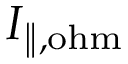Convert formula to latex. <formula><loc_0><loc_0><loc_500><loc_500>I _ { \| , o h m }</formula> 